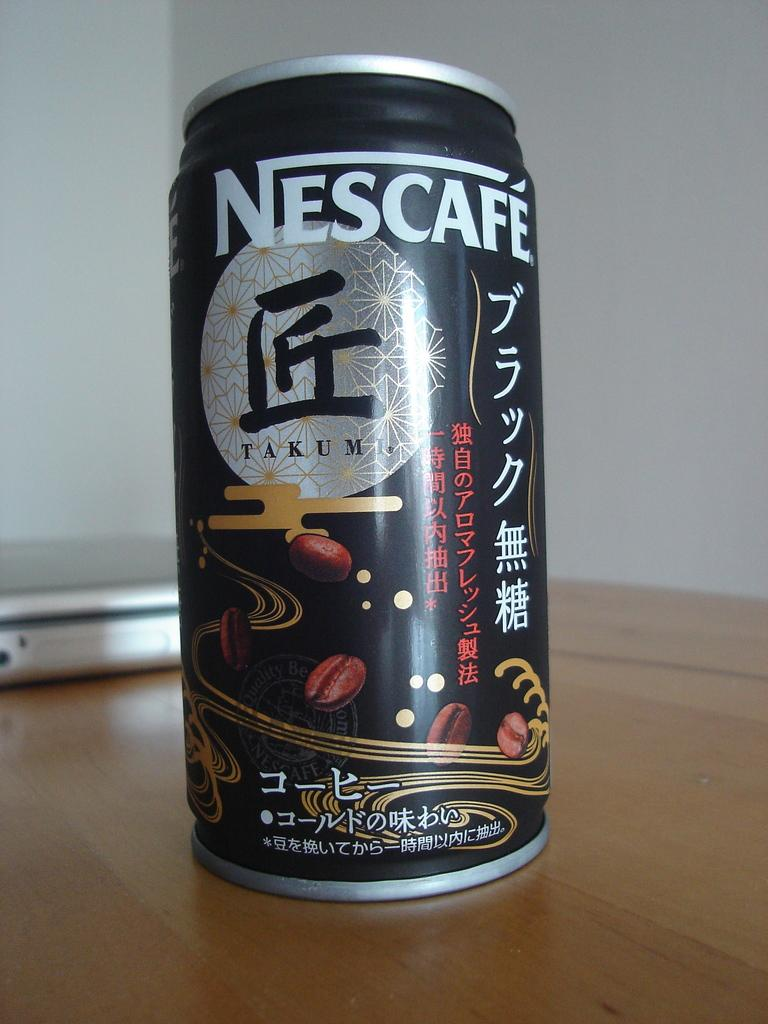<image>
Describe the image concisely. A drink from Nescafe with kanji writing on the can 